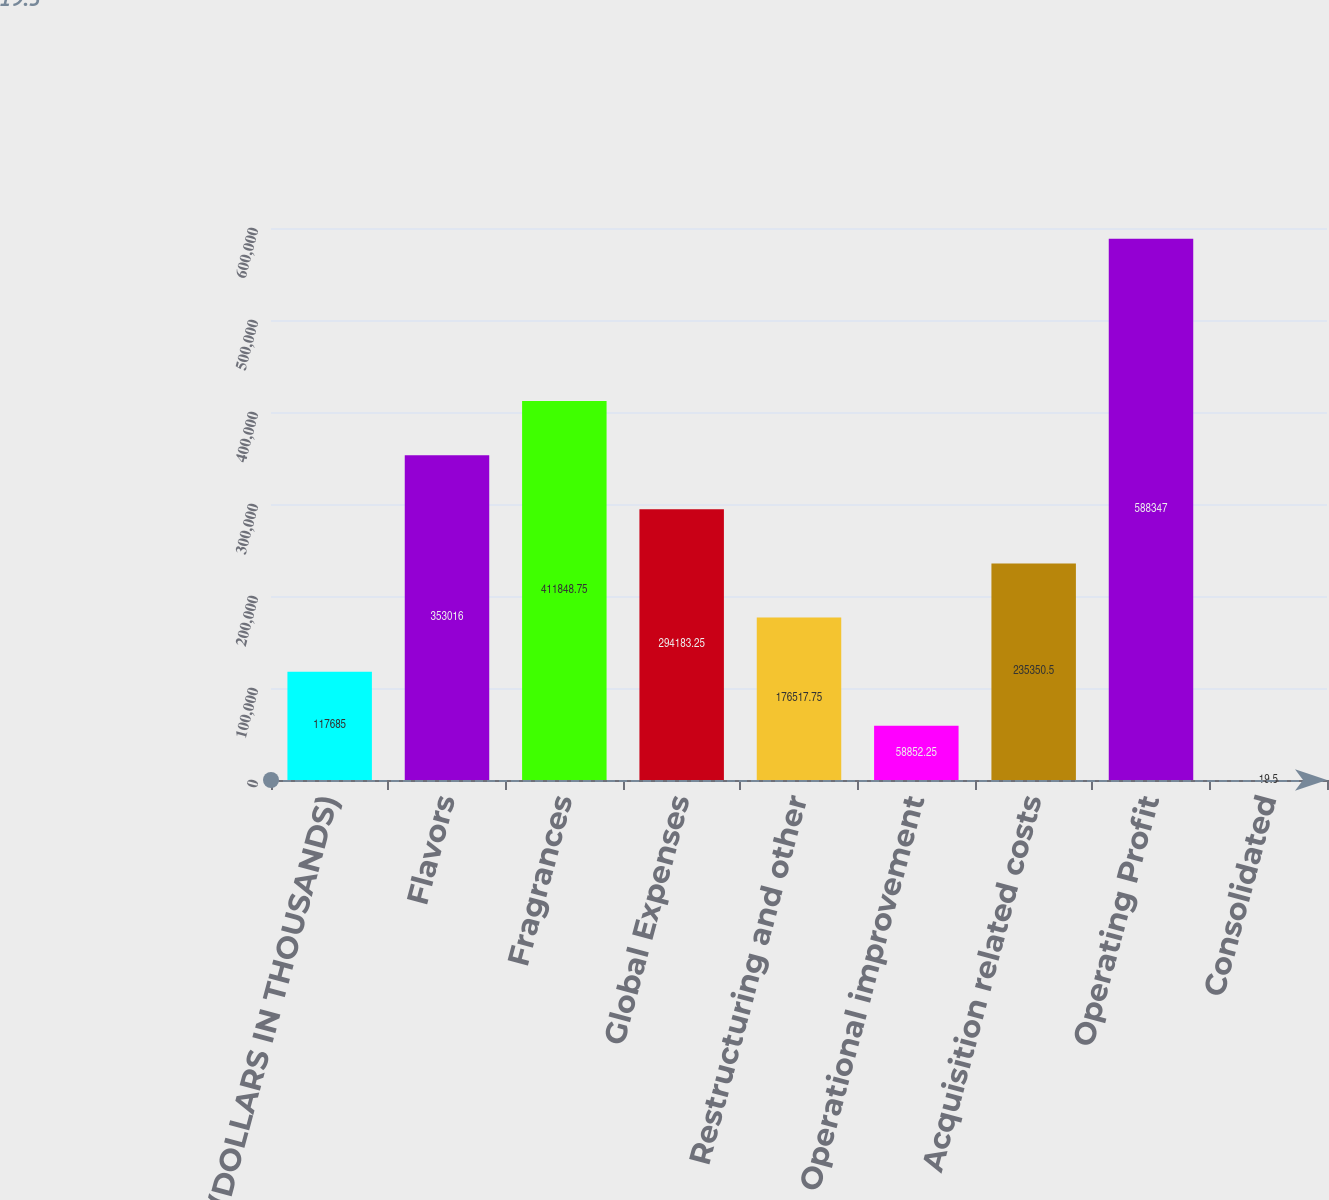Convert chart. <chart><loc_0><loc_0><loc_500><loc_500><bar_chart><fcel>(DOLLARS IN THOUSANDS)<fcel>Flavors<fcel>Fragrances<fcel>Global Expenses<fcel>Restructuring and other<fcel>Operational improvement<fcel>Acquisition related costs<fcel>Operating Profit<fcel>Consolidated<nl><fcel>117685<fcel>353016<fcel>411849<fcel>294183<fcel>176518<fcel>58852.2<fcel>235350<fcel>588347<fcel>19.5<nl></chart> 